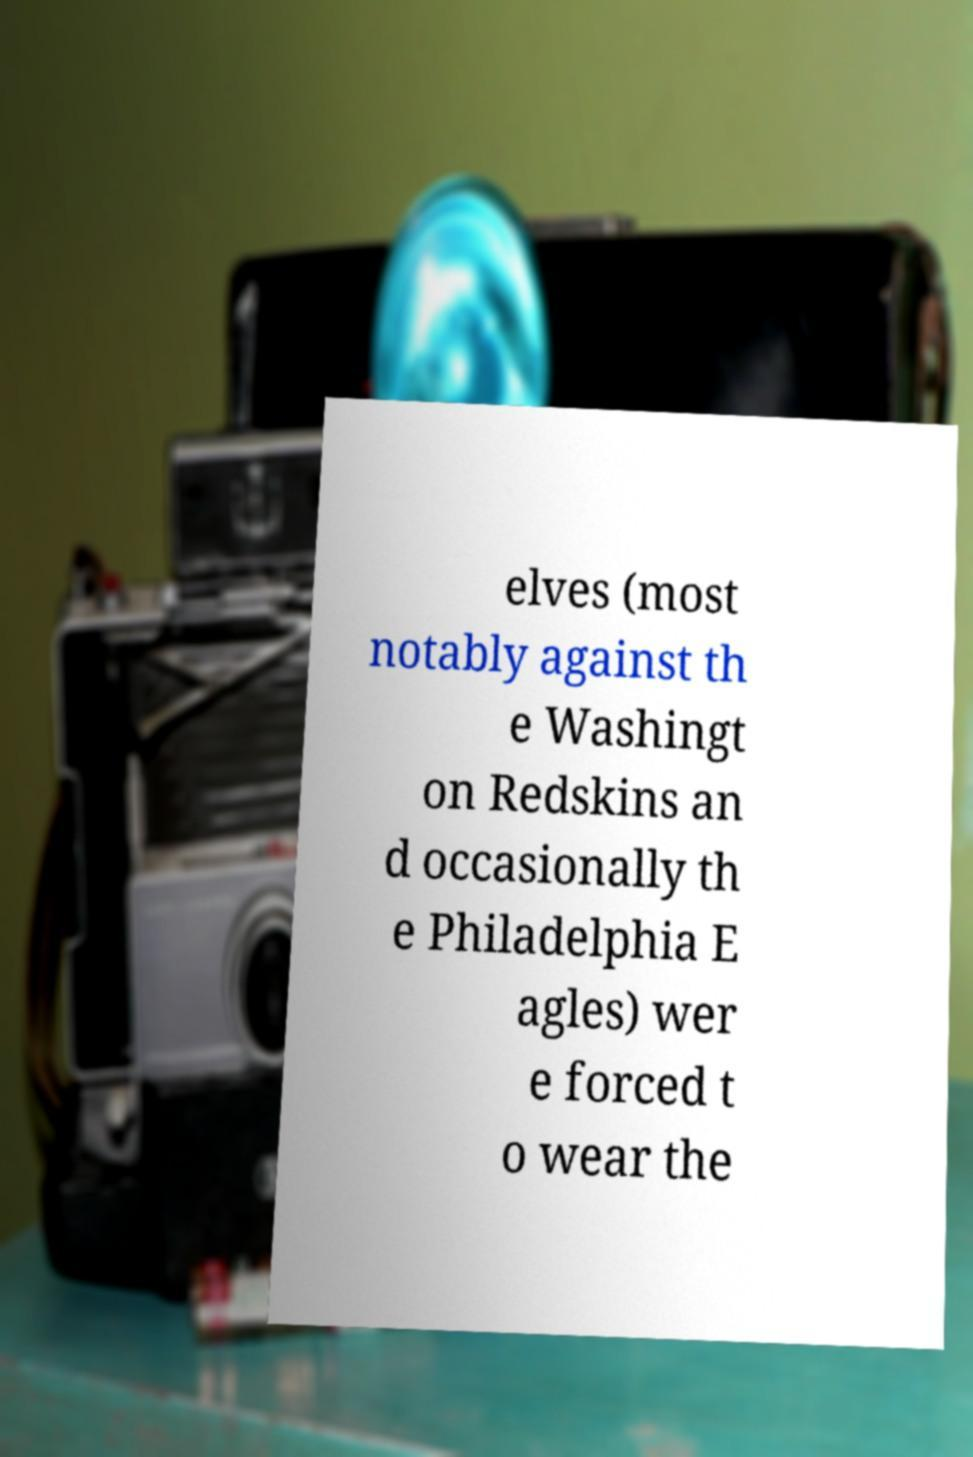Could you assist in decoding the text presented in this image and type it out clearly? elves (most notably against th e Washingt on Redskins an d occasionally th e Philadelphia E agles) wer e forced t o wear the 